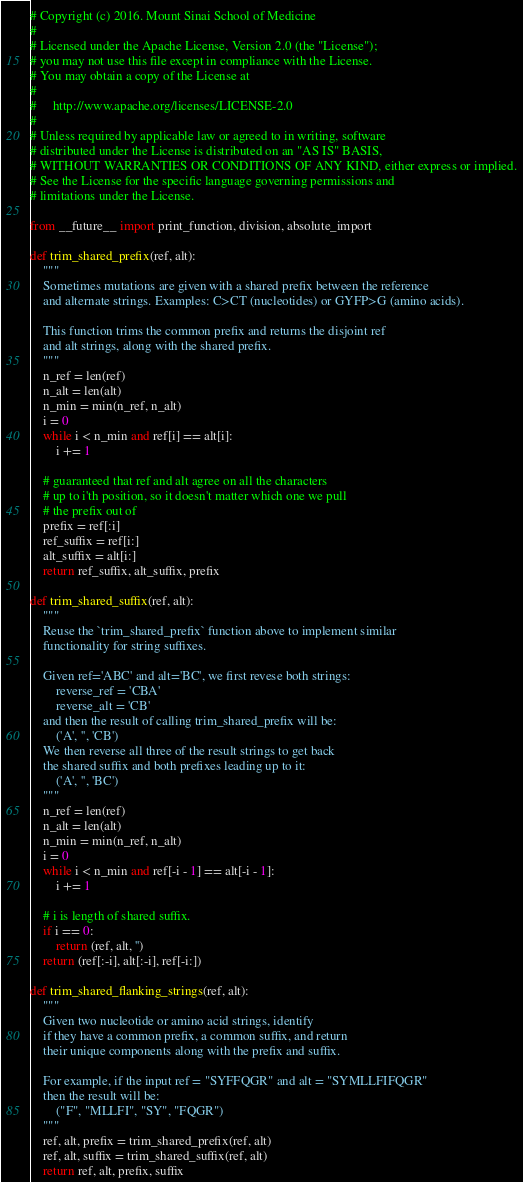Convert code to text. <code><loc_0><loc_0><loc_500><loc_500><_Python_># Copyright (c) 2016. Mount Sinai School of Medicine
#
# Licensed under the Apache License, Version 2.0 (the "License");
# you may not use this file except in compliance with the License.
# You may obtain a copy of the License at
#
#     http://www.apache.org/licenses/LICENSE-2.0
#
# Unless required by applicable law or agreed to in writing, software
# distributed under the License is distributed on an "AS IS" BASIS,
# WITHOUT WARRANTIES OR CONDITIONS OF ANY KIND, either express or implied.
# See the License for the specific language governing permissions and
# limitations under the License.

from __future__ import print_function, division, absolute_import

def trim_shared_prefix(ref, alt):
    """
    Sometimes mutations are given with a shared prefix between the reference
    and alternate strings. Examples: C>CT (nucleotides) or GYFP>G (amino acids).

    This function trims the common prefix and returns the disjoint ref
    and alt strings, along with the shared prefix.
    """
    n_ref = len(ref)
    n_alt = len(alt)
    n_min = min(n_ref, n_alt)
    i = 0
    while i < n_min and ref[i] == alt[i]:
        i += 1

    # guaranteed that ref and alt agree on all the characters
    # up to i'th position, so it doesn't matter which one we pull
    # the prefix out of
    prefix = ref[:i]
    ref_suffix = ref[i:]
    alt_suffix = alt[i:]
    return ref_suffix, alt_suffix, prefix

def trim_shared_suffix(ref, alt):
    """
    Reuse the `trim_shared_prefix` function above to implement similar
    functionality for string suffixes.

    Given ref='ABC' and alt='BC', we first revese both strings:
        reverse_ref = 'CBA'
        reverse_alt = 'CB'
    and then the result of calling trim_shared_prefix will be:
        ('A', '', 'CB')
    We then reverse all three of the result strings to get back
    the shared suffix and both prefixes leading up to it:
        ('A', '', 'BC')
    """
    n_ref = len(ref)
    n_alt = len(alt)
    n_min = min(n_ref, n_alt)
    i = 0
    while i < n_min and ref[-i - 1] == alt[-i - 1]:
        i += 1

    # i is length of shared suffix.
    if i == 0:
        return (ref, alt, '')
    return (ref[:-i], alt[:-i], ref[-i:])

def trim_shared_flanking_strings(ref, alt):
    """
    Given two nucleotide or amino acid strings, identify
    if they have a common prefix, a common suffix, and return
    their unique components along with the prefix and suffix.

    For example, if the input ref = "SYFFQGR" and alt = "SYMLLFIFQGR"
    then the result will be:
        ("F", "MLLFI", "SY", "FQGR")
    """
    ref, alt, prefix = trim_shared_prefix(ref, alt)
    ref, alt, suffix = trim_shared_suffix(ref, alt)
    return ref, alt, prefix, suffix
</code> 